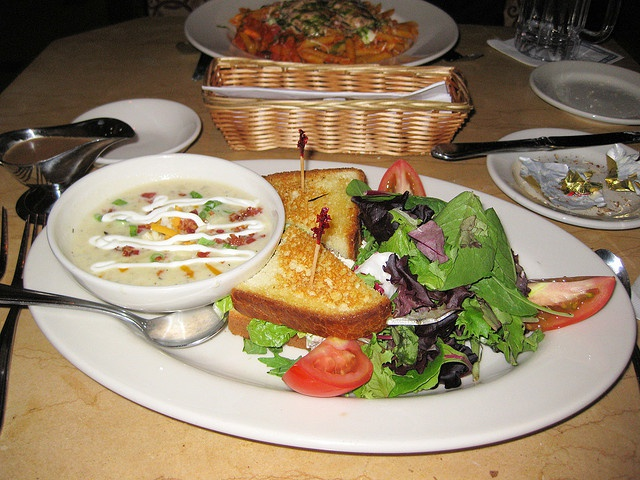Describe the objects in this image and their specific colors. I can see dining table in black and tan tones, bowl in black, lightgray, tan, and darkgray tones, sandwich in black, brown, orange, tan, and khaki tones, sandwich in black, red, tan, orange, and olive tones, and spoon in black, darkgray, ivory, and gray tones in this image. 